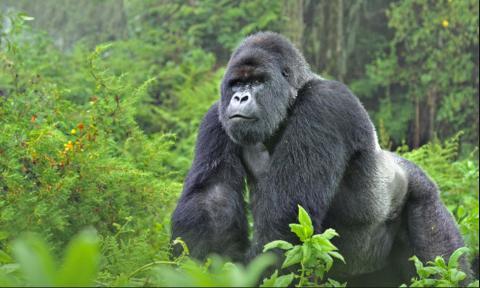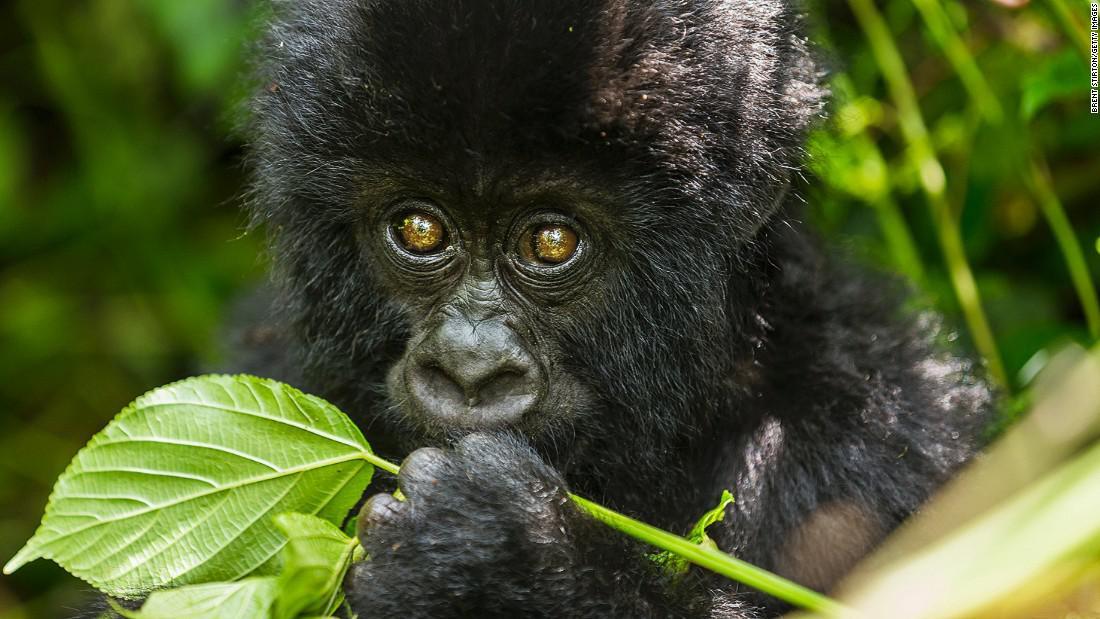The first image is the image on the left, the second image is the image on the right. Examine the images to the left and right. Is the description "One image shows a man interacting with a gorilla, with one of them in front of the other but their bodies not facing, and the man is holding on to one of the gorilla's hands." accurate? Answer yes or no. No. The first image is the image on the left, the second image is the image on the right. Evaluate the accuracy of this statement regarding the images: "I human is interacting with an ape.". Is it true? Answer yes or no. No. 